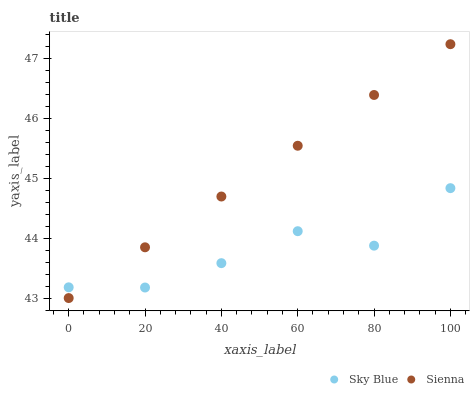Does Sky Blue have the minimum area under the curve?
Answer yes or no. Yes. Does Sienna have the maximum area under the curve?
Answer yes or no. Yes. Does Sky Blue have the maximum area under the curve?
Answer yes or no. No. Is Sienna the smoothest?
Answer yes or no. Yes. Is Sky Blue the roughest?
Answer yes or no. Yes. Is Sky Blue the smoothest?
Answer yes or no. No. Does Sienna have the lowest value?
Answer yes or no. Yes. Does Sky Blue have the lowest value?
Answer yes or no. No. Does Sienna have the highest value?
Answer yes or no. Yes. Does Sky Blue have the highest value?
Answer yes or no. No. Does Sky Blue intersect Sienna?
Answer yes or no. Yes. Is Sky Blue less than Sienna?
Answer yes or no. No. Is Sky Blue greater than Sienna?
Answer yes or no. No. 